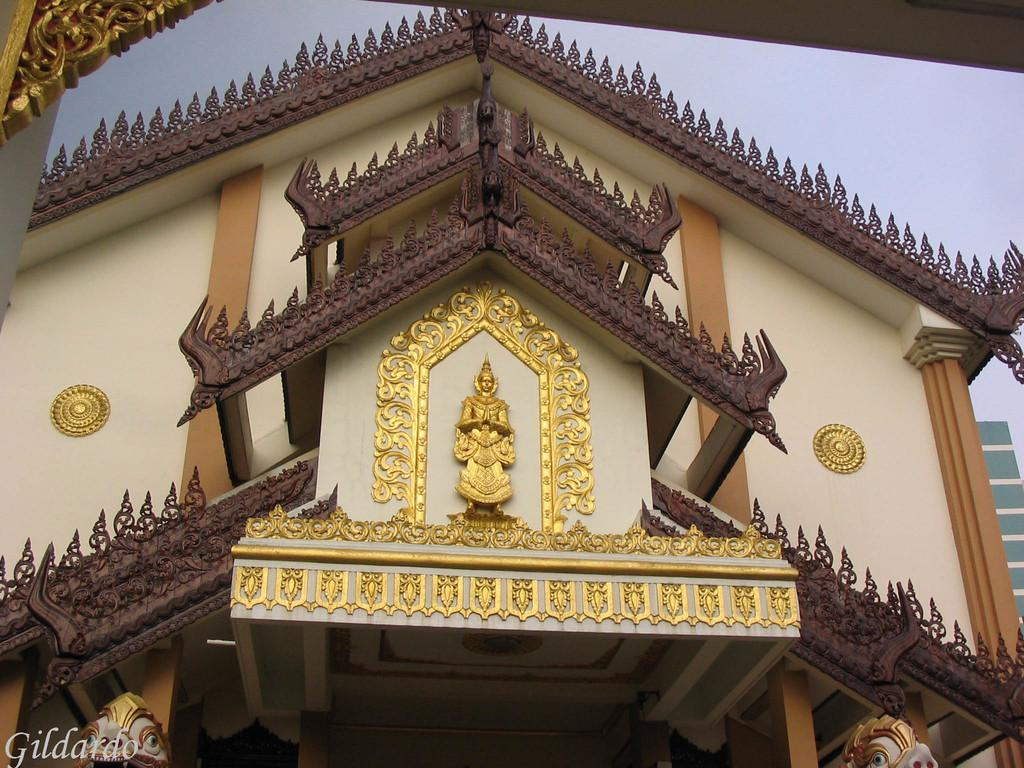What type of scene is depicted in the image? The image appears to depict an architectural structure. Are there any additional features on the structure? Yes, there is a sculpture on the structure. What other objects can be seen at the bottom of the image? There are two statues at the bottom of the image. What is visible at the top of the image? The sky is visible at the top of the image. What sense does the cannon represent in the image? There is no cannon present in the image, so it does not represent any sense. 